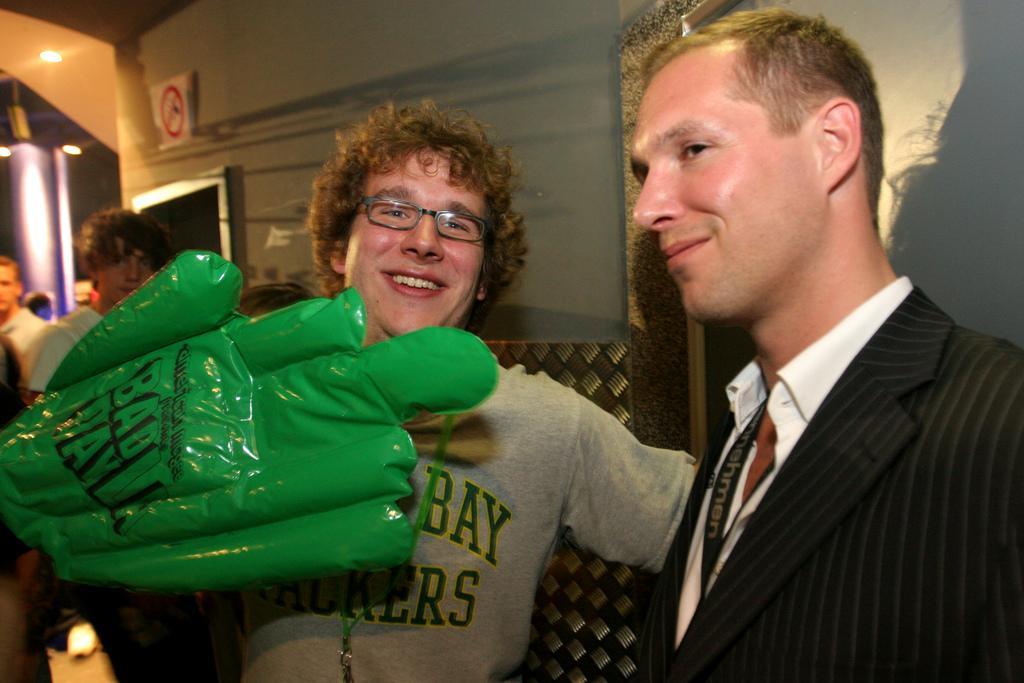Can you describe this image briefly? Here I can see two men standing and smiling. On the left side there is a green color hand glove and also I can see few people are standing. In the background there is a wall. In the top left-hand corner there are few lights attached to the roof. On the right side there is a board. 